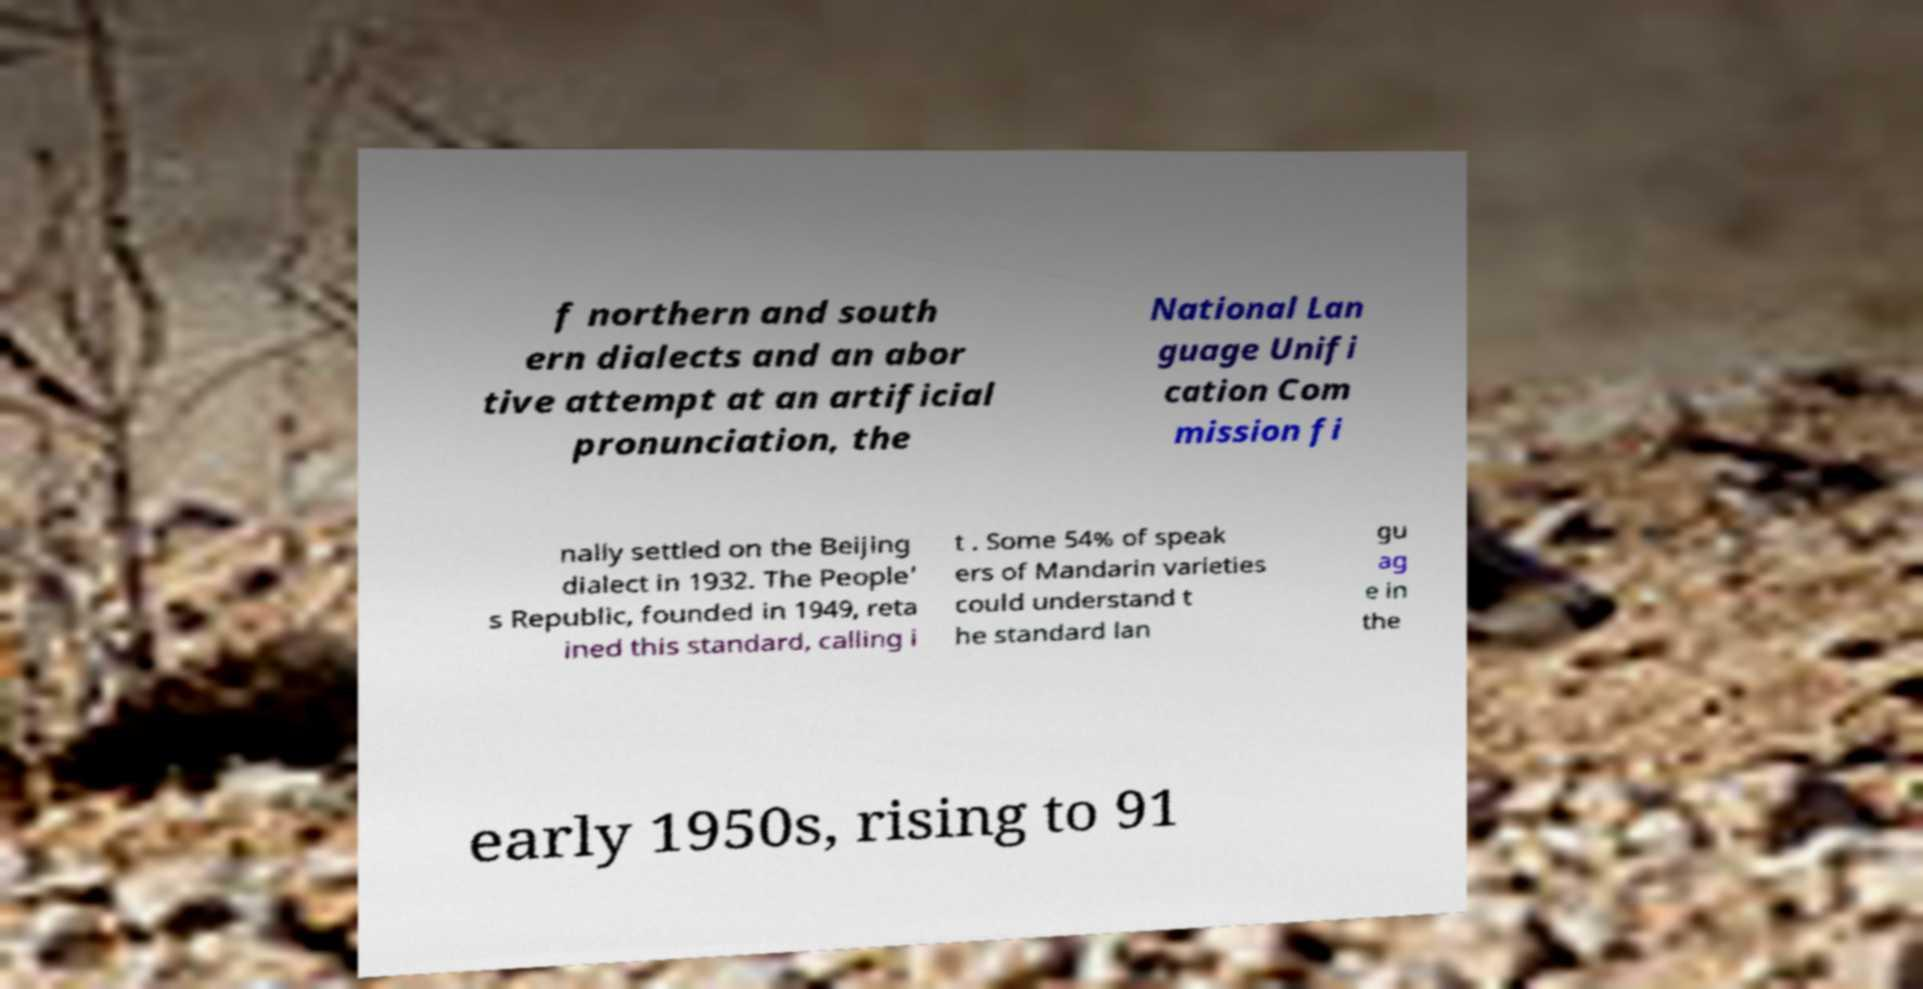Please identify and transcribe the text found in this image. f northern and south ern dialects and an abor tive attempt at an artificial pronunciation, the National Lan guage Unifi cation Com mission fi nally settled on the Beijing dialect in 1932. The People' s Republic, founded in 1949, reta ined this standard, calling i t . Some 54% of speak ers of Mandarin varieties could understand t he standard lan gu ag e in the early 1950s, rising to 91 